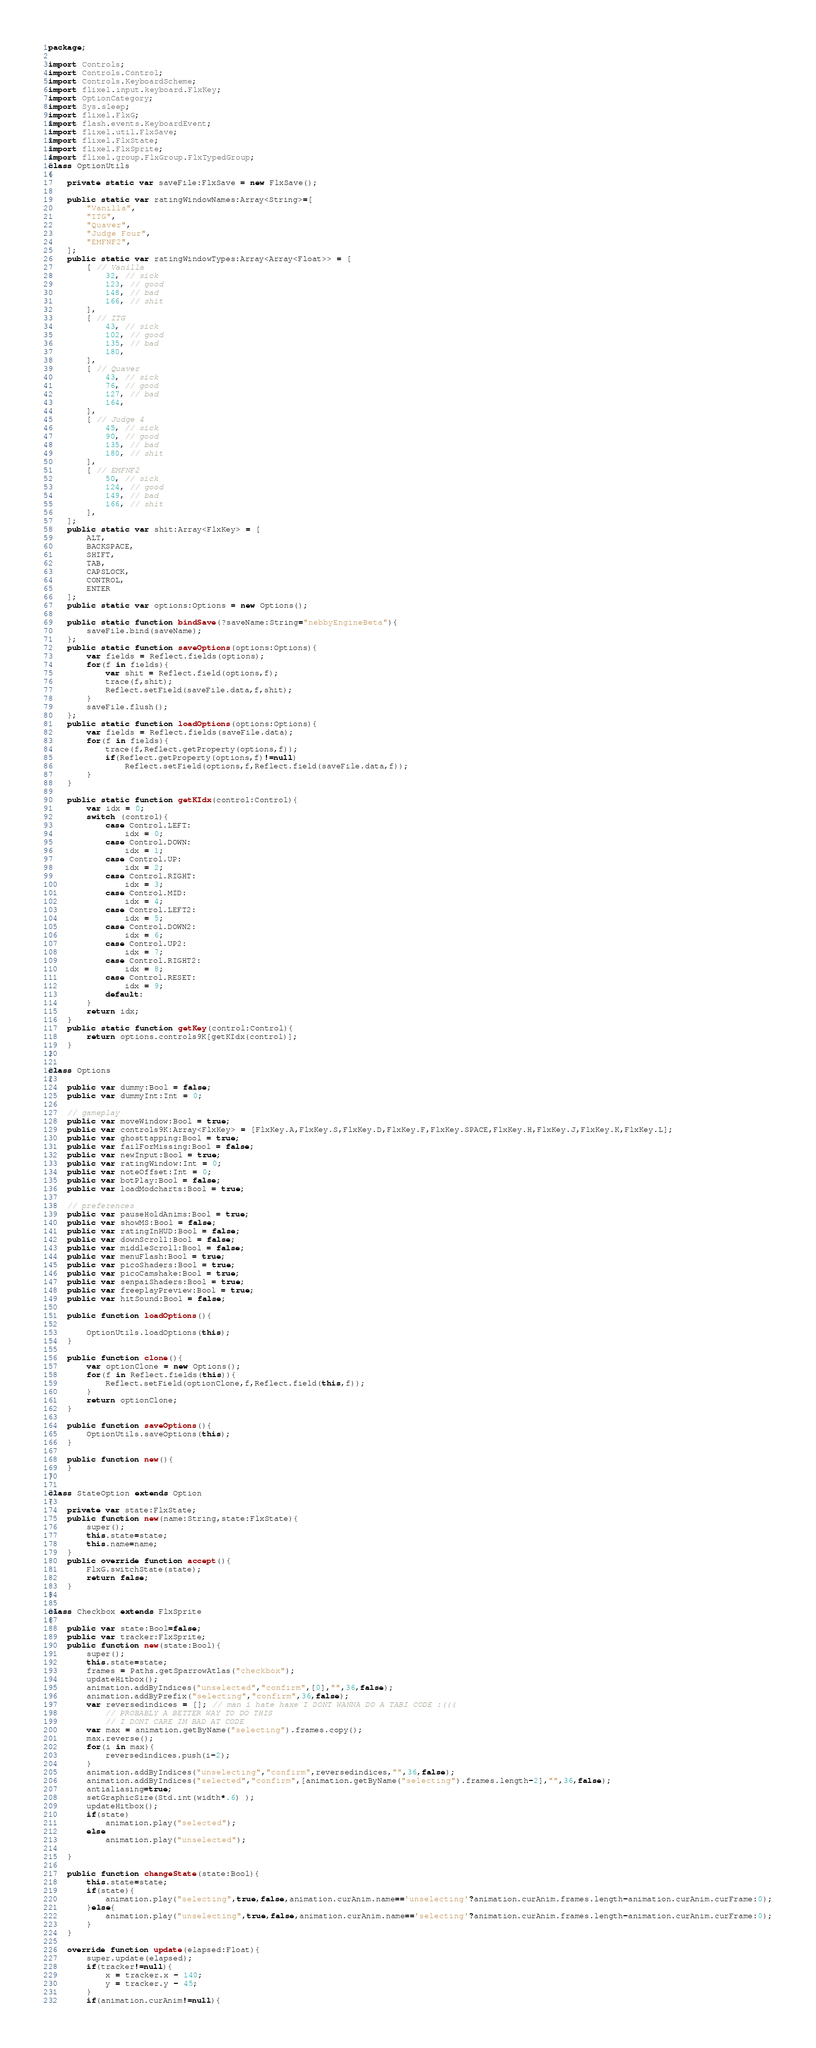Convert code to text. <code><loc_0><loc_0><loc_500><loc_500><_Haxe_>package;

import Controls;
import Controls.Control;
import Controls.KeyboardScheme;
import flixel.input.keyboard.FlxKey;
import OptionCategory;
import Sys.sleep;
import flixel.FlxG;
import flash.events.KeyboardEvent;
import flixel.util.FlxSave;
import flixel.FlxState;
import flixel.FlxSprite;
import flixel.group.FlxGroup.FlxTypedGroup;
class OptionUtils
{
	private static var saveFile:FlxSave = new FlxSave();

	public static var ratingWindowNames:Array<String>=[
		"Vanilla",
		"ITG",
		"Quaver",
		"Judge Four",
		"EMFNF2",
	];
	public static var ratingWindowTypes:Array<Array<Float>> = [
		[ // Vanilla
			32, // sick
			123, // good
			148, // bad
			166, // shit
		],
		[ // ITG
			43, // sick
			102, // good
			135, // bad
			180,
		],
		[ // Quaver
			43, // sick
			76, // good
			127, // bad
			164,
		],
		[ // Judge 4
			45, // sick
			90, // good
			135, // bad
			180, // shit
		],
		[ // EMFNF2
			50, // sick
			124, // good
			149, // bad
			166, // shit
		],
	];
	public static var shit:Array<FlxKey> = [
		ALT,
		BACKSPACE,
		SHIFT,
		TAB,
		CAPSLOCK,
		CONTROL,
		ENTER
	];
	public static var options:Options = new Options();

	public static function bindSave(?saveName:String="nebbyEngineBeta"){
		saveFile.bind(saveName);
	};
	public static function saveOptions(options:Options){
		var fields = Reflect.fields(options);
		for(f in fields){
			var shit = Reflect.field(options,f);
			trace(f,shit);
			Reflect.setField(saveFile.data,f,shit);
		}
		saveFile.flush();
	};
	public static function loadOptions(options:Options){
		var fields = Reflect.fields(saveFile.data);
		for(f in fields){
			trace(f,Reflect.getProperty(options,f));
			if(Reflect.getProperty(options,f)!=null)
				Reflect.setField(options,f,Reflect.field(saveFile.data,f));
		}
	}

	public static function getKIdx(control:Control){
		var idx = 0;
		switch (control){
			case Control.LEFT:
				idx = 0;
			case Control.DOWN:
				idx = 1;
			case Control.UP:
				idx = 2;
			case Control.RIGHT:
				idx = 3;
			case Control.MID:
				idx = 4;
			case Control.LEFT2:
				idx = 5;
			case Control.DOWN2:
				idx = 6;
			case Control.UP2:
				idx = 7;
			case Control.RIGHT2:
				idx = 8;
			case Control.RESET:
				idx = 9;
			default:
		}
		return idx;
	}
	public static function getKey(control:Control){
		return options.controls9K[getKIdx(control)];
	}
}

class Options
{
	public var dummy:Bool = false;
	public var dummyInt:Int = 0;

	// gameplay
	public var moveWindow:Bool = true;
	public var controls9K:Array<FlxKey> = [FlxKey.A,FlxKey.S,FlxKey.D,FlxKey.F,FlxKey.SPACE,FlxKey.H,FlxKey.J,FlxKey.K,FlxKey.L];
	public var ghosttapping:Bool = true;
	public var failForMissing:Bool = false;
	public var newInput:Bool = true;
	public var ratingWindow:Int = 0;
	public var noteOffset:Int = 0;
	public var botPlay:Bool = false;
	public var loadModcharts:Bool = true;

	// preferences
	public var pauseHoldAnims:Bool = true;
	public var showMS:Bool = false;
	public var ratingInHUD:Bool = false;
	public var downScroll:Bool = false;
	public var middleScroll:Bool = false;
	public var menuFlash:Bool = true;
	public var picoShaders:Bool = true;
	public var picoCamshake:Bool = true;
	public var senpaiShaders:Bool = true;
	public var freeplayPreview:Bool = true;
	public var hitSound:Bool = false;

	public function loadOptions(){

		OptionUtils.loadOptions(this);
	}

	public function clone(){
		var optionClone = new Options();
		for(f in Reflect.fields(this)){
			Reflect.setField(optionClone,f,Reflect.field(this,f));
		}
		return optionClone;
	}

	public function saveOptions(){
		OptionUtils.saveOptions(this);
	}

	public function new(){
	}
}

class StateOption extends Option
{
	private var state:FlxState;
	public function new(name:String,state:FlxState){
		super();
		this.state=state;
		this.name=name;
	}
	public override function accept(){
		FlxG.switchState(state);
		return false;
	}
}

class Checkbox extends FlxSprite
{
	public var state:Bool=false;
	public var tracker:FlxSprite;
	public function new(state:Bool){
		super();
		this.state=state;
		frames = Paths.getSparrowAtlas("checkbox");
		updateHitbox();
		animation.addByIndices("unselected","confirm",[0],"",36,false);
		animation.addByPrefix("selecting","confirm",36,false);
		var reversedindices = []; // man i hate haxe I DONT WANNA DO A TABI CODE :(((
			// PROBABLY A BETTER WAY TO DO THIS
			// I DONT CARE IM BAD AT CODE
		var max = animation.getByName("selecting").frames.copy();
		max.reverse();
		for(i in max){
			reversedindices.push(i-2);
		}
		animation.addByIndices("unselecting","confirm",reversedindices,"",36,false);
		animation.addByIndices("selected","confirm",[animation.getByName("selecting").frames.length-2],"",36,false);
		antialiasing=true;
		setGraphicSize(Std.int(width*.6) );
		updateHitbox();
		if(state)
			animation.play("selected");
		else
			animation.play("unselected");

	}

	public function changeState(state:Bool){
		this.state=state;
		if(state){
			animation.play("selecting",true,false,animation.curAnim.name=='unselecting'?animation.curAnim.frames.length-animation.curAnim.curFrame:0);
		}else{
			animation.play("unselecting",true,false,animation.curAnim.name=='selecting'?animation.curAnim.frames.length-animation.curAnim.curFrame:0);
		}
	}

	override function update(elapsed:Float){
		super.update(elapsed);
		if(tracker!=null){
			x = tracker.x - 140;
			y = tracker.y - 45;
		}
		if(animation.curAnim!=null){
</code> 